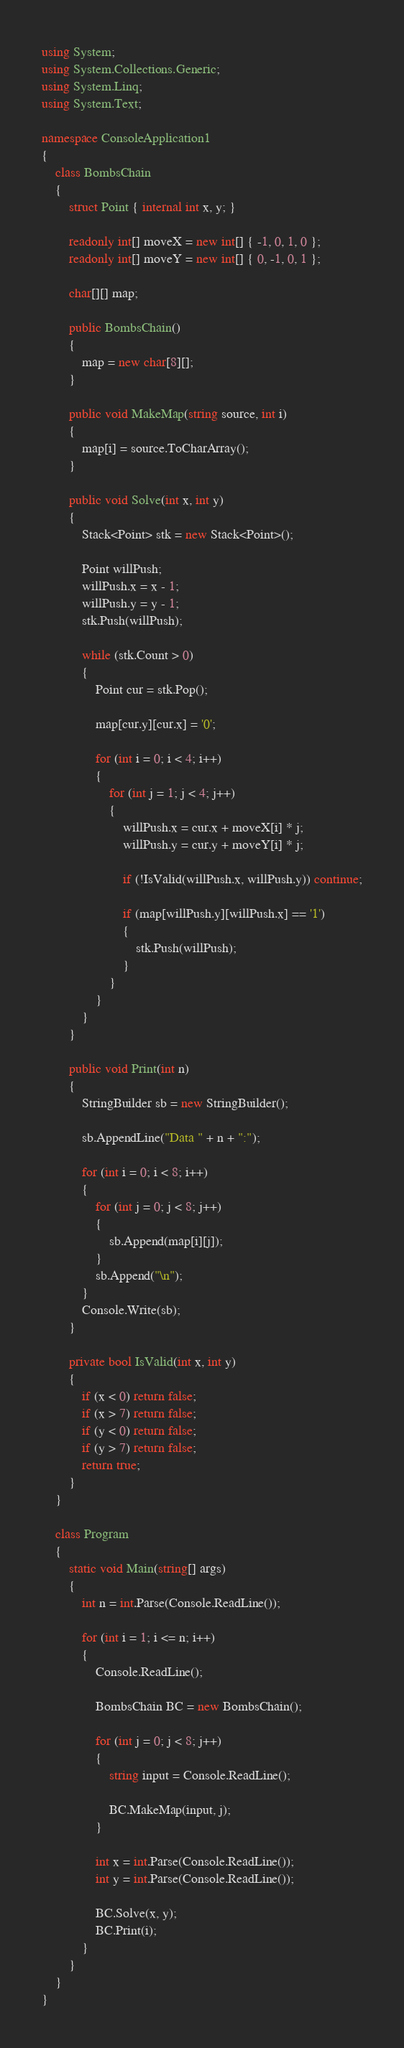<code> <loc_0><loc_0><loc_500><loc_500><_C#_>using System;
using System.Collections.Generic;
using System.Linq;
using System.Text;

namespace ConsoleApplication1
{
    class BombsChain
    {
        struct Point { internal int x, y; }

        readonly int[] moveX = new int[] { -1, 0, 1, 0 };
        readonly int[] moveY = new int[] { 0, -1, 0, 1 };

        char[][] map;

        public BombsChain()
        {
            map = new char[8][];
        }

        public void MakeMap(string source, int i)
        {
            map[i] = source.ToCharArray();
        }

        public void Solve(int x, int y)
        {
            Stack<Point> stk = new Stack<Point>();

            Point willPush;
            willPush.x = x - 1;
            willPush.y = y - 1;
            stk.Push(willPush);

            while (stk.Count > 0)
            {
                Point cur = stk.Pop();

                map[cur.y][cur.x] = '0';

                for (int i = 0; i < 4; i++)
                {
                    for (int j = 1; j < 4; j++)
                    {
                        willPush.x = cur.x + moveX[i] * j;
                        willPush.y = cur.y + moveY[i] * j;

                        if (!IsValid(willPush.x, willPush.y)) continue;

                        if (map[willPush.y][willPush.x] == '1')
                        {
                            stk.Push(willPush);
                        }
                    }
                }
            }
        }

        public void Print(int n)
        {
            StringBuilder sb = new StringBuilder();

            sb.AppendLine("Data " + n + ":");

            for (int i = 0; i < 8; i++)
            {
                for (int j = 0; j < 8; j++)
                {
                    sb.Append(map[i][j]);
                }
                sb.Append("\n");
            }
            Console.Write(sb);
        }

        private bool IsValid(int x, int y)
        {
            if (x < 0) return false;
            if (x > 7) return false;
            if (y < 0) return false;
            if (y > 7) return false;
            return true;
        }
    }

    class Program
    {
        static void Main(string[] args)
        {
            int n = int.Parse(Console.ReadLine());

            for (int i = 1; i <= n; i++)
            {
                Console.ReadLine();

                BombsChain BC = new BombsChain();

                for (int j = 0; j < 8; j++)
                {
                    string input = Console.ReadLine();

                    BC.MakeMap(input, j);
                }

                int x = int.Parse(Console.ReadLine());
                int y = int.Parse(Console.ReadLine());

                BC.Solve(x, y);
                BC.Print(i);
            }
        }
    }
}</code> 